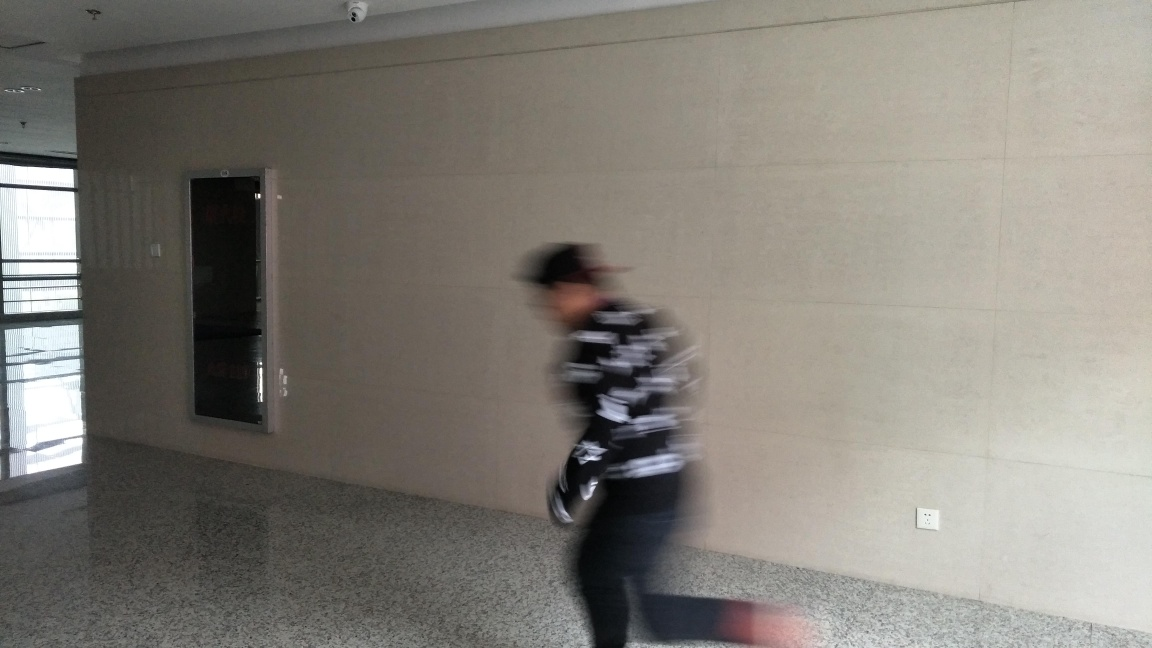What kind of atmosphere or feeling does this image evoke? The image evokes a transient and somewhat impersonal atmosphere, common to public or semi-public spaces like office buildings, airports, or medical facilities. The blurred figure and the stark walls contribute further to a sense of anonymity and the fleeting nature of individual presence in such environments. 